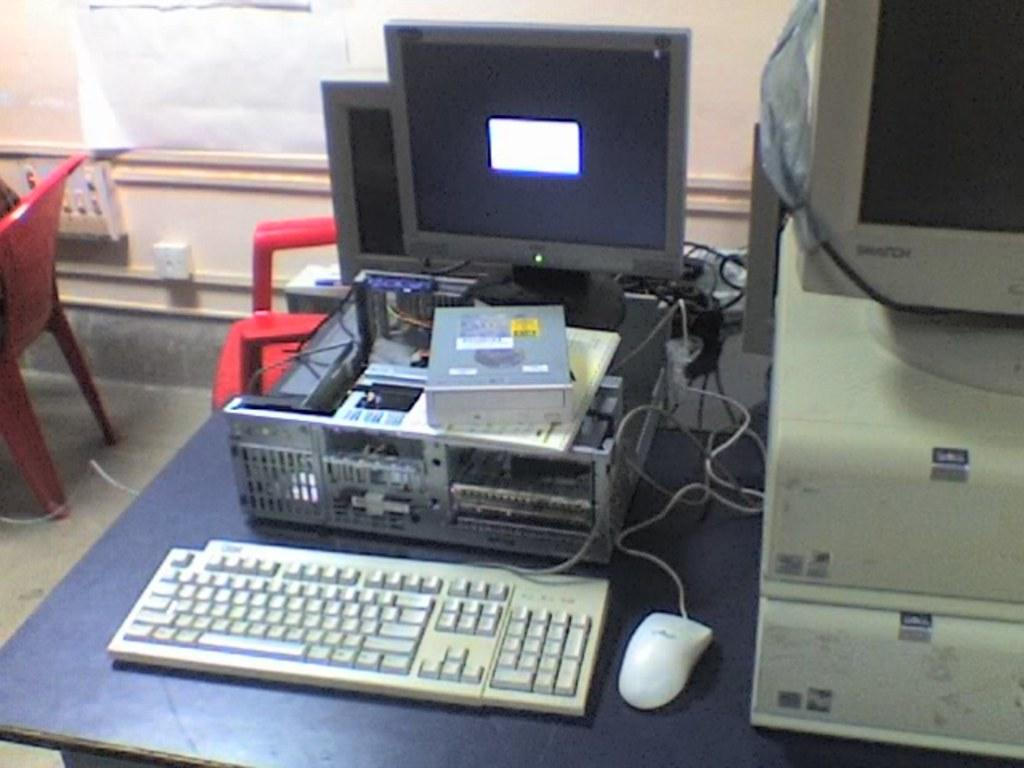What type of electronic device is visible in the image? There is a monitor in the image. What other computer components can be seen in the image? There is a CPU, a mouse, and a keyboard visible in the image. Where are these computer components located? The monitor, CPU, mouse, and keyboard are placed on a table in the image. How many chairs are present in the image? There are two chairs in the image. What is installed on the wall in the image? There is a plug board installed on the wall. What type of bedroom furniture is visible in the image? There is no bedroom furniture visible in the image; it features computer components and accessories. What type of fuel is being used by the computer in the image? Computers do not use fuel; they are powered by electricity. What part of the human brain can be seen in the image? There is no human brain visible in the image; it features computer components and accessories. 